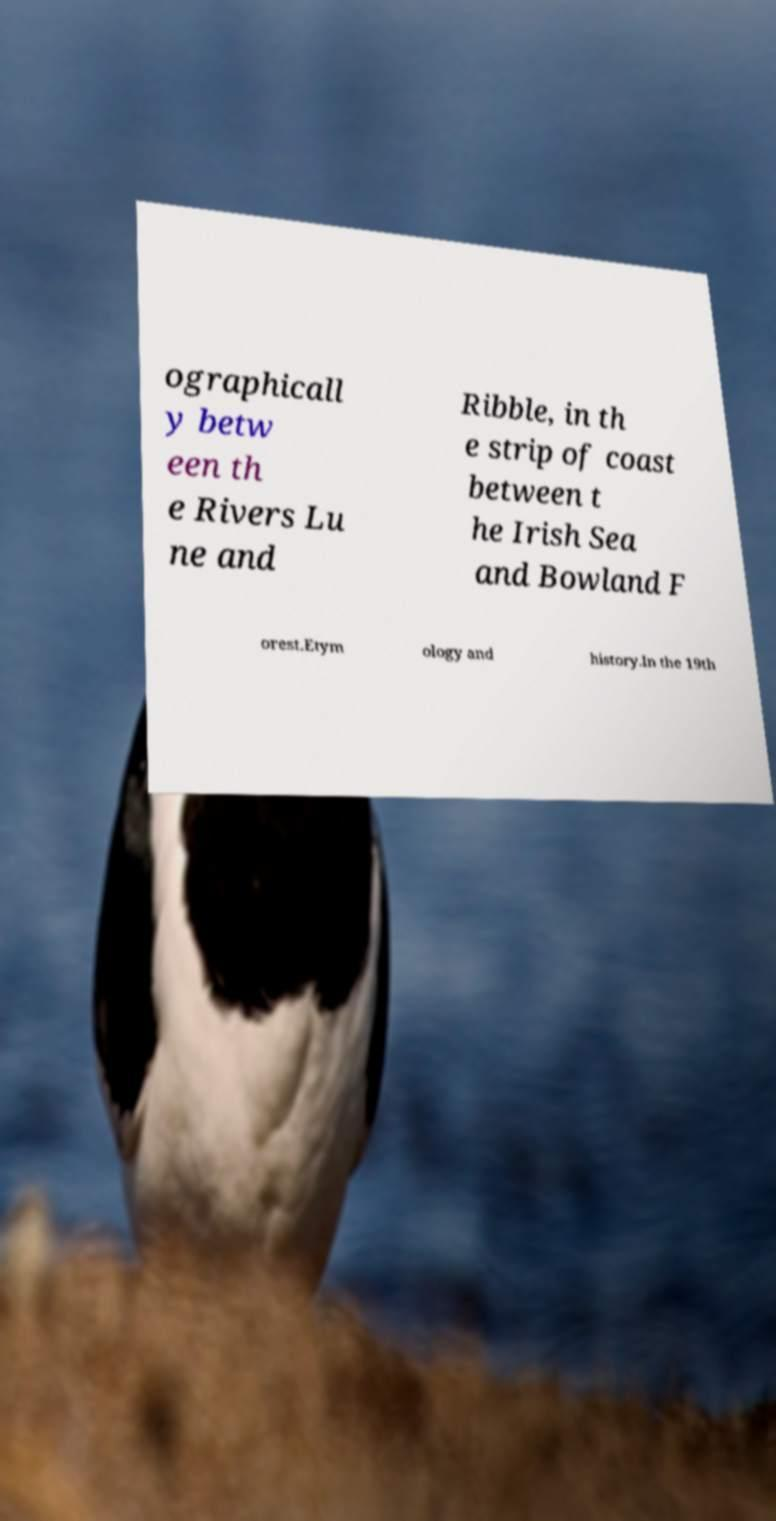Can you accurately transcribe the text from the provided image for me? ographicall y betw een th e Rivers Lu ne and Ribble, in th e strip of coast between t he Irish Sea and Bowland F orest.Etym ology and history.In the 19th 